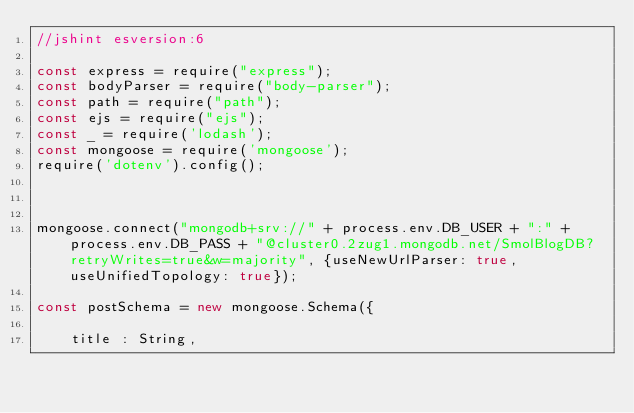Convert code to text. <code><loc_0><loc_0><loc_500><loc_500><_JavaScript_>//jshint esversion:6

const express = require("express");
const bodyParser = require("body-parser");
const path = require("path");
const ejs = require("ejs");
const _ = require('lodash');
const mongoose = require('mongoose');
require('dotenv').config();



mongoose.connect("mongodb+srv://" + process.env.DB_USER + ":" + process.env.DB_PASS + "@cluster0.2zug1.mongodb.net/SmolBlogDB?retryWrites=true&w=majority", {useNewUrlParser: true, useUnifiedTopology: true});

const postSchema = new mongoose.Schema({
   
    title : String, </code> 